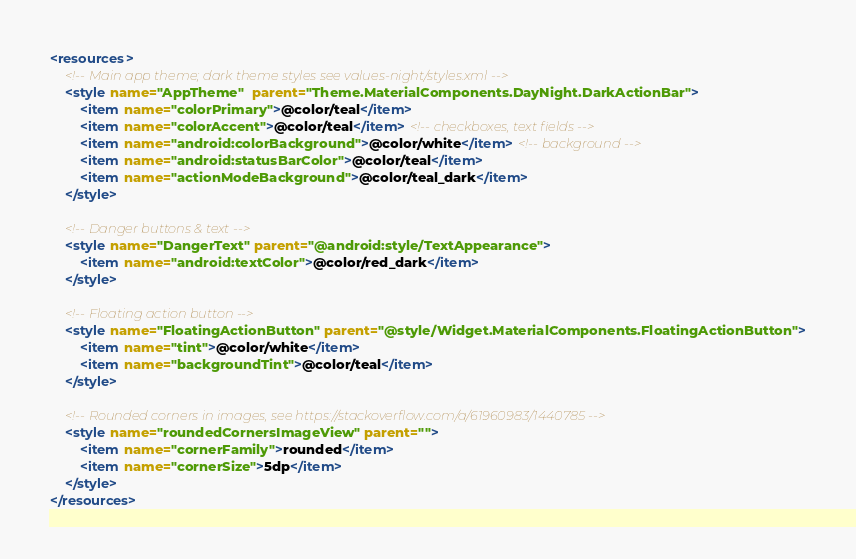<code> <loc_0><loc_0><loc_500><loc_500><_XML_><resources>
    <!-- Main app theme; dark theme styles see values-night/styles.xml -->
    <style name="AppTheme"  parent="Theme.MaterialComponents.DayNight.DarkActionBar">
        <item name="colorPrimary">@color/teal</item>
        <item name="colorAccent">@color/teal</item> <!-- checkboxes, text fields -->
        <item name="android:colorBackground">@color/white</item> <!-- background -->
        <item name="android:statusBarColor">@color/teal</item>
        <item name="actionModeBackground">@color/teal_dark</item>
    </style>

    <!-- Danger buttons & text -->
    <style name="DangerText" parent="@android:style/TextAppearance">
        <item name="android:textColor">@color/red_dark</item>
    </style>

    <!-- Floating action button -->
    <style name="FloatingActionButton" parent="@style/Widget.MaterialComponents.FloatingActionButton">
        <item name="tint">@color/white</item>
        <item name="backgroundTint">@color/teal</item>
    </style>

    <!-- Rounded corners in images, see https://stackoverflow.com/a/61960983/1440785 -->
    <style name="roundedCornersImageView" parent="">
        <item name="cornerFamily">rounded</item>
        <item name="cornerSize">5dp</item>
    </style>
</resources>
</code> 